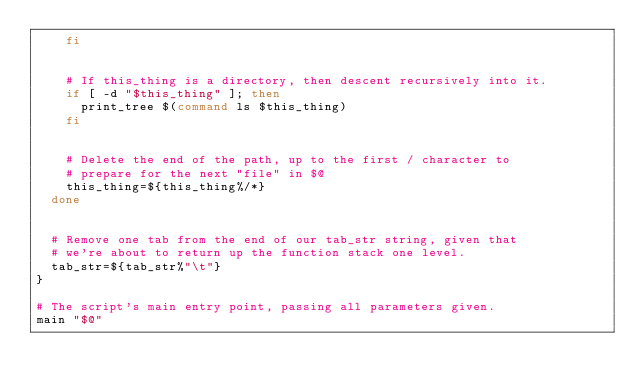Convert code to text. <code><loc_0><loc_0><loc_500><loc_500><_Bash_>		fi
		
		
		# If this_thing is a directory, then descent recursively into it.
		if [ -d "$this_thing" ]; then
			print_tree $(command ls $this_thing)
		fi
		
		
		# Delete the end of the path, up to the first / character to
		# prepare for the next "file" in $@
		this_thing=${this_thing%/*}
	done
	
	
	# Remove one tab from the end of our tab_str string, given that
	# we're about to return up the function stack one level.
	tab_str=${tab_str%"\t"}
}

# The script's main entry point, passing all parameters given.
main "$@"

</code> 